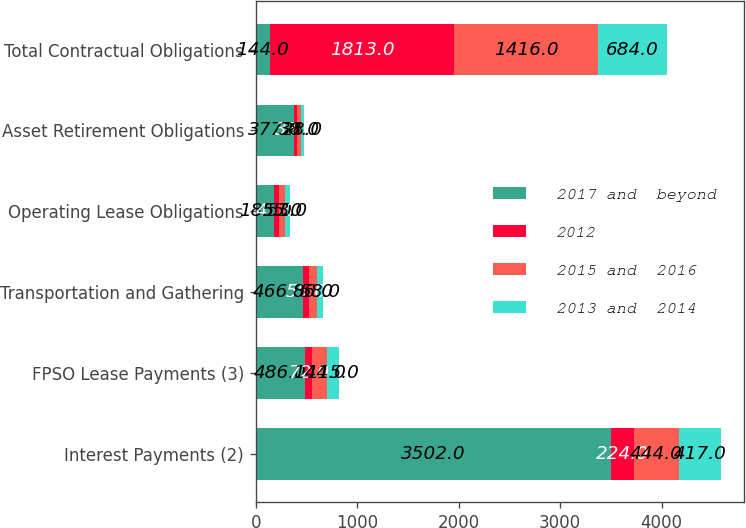Convert chart to OTSL. <chart><loc_0><loc_0><loc_500><loc_500><stacked_bar_chart><ecel><fcel>Interest Payments (2)<fcel>FPSO Lease Payments (3)<fcel>Transportation and Gathering<fcel>Operating Lease Obligations<fcel>Asset Retirement Obligations<fcel>Total Contractual Obligations<nl><fcel>2017 and  beyond<fcel>3502<fcel>486<fcel>466<fcel>185<fcel>377<fcel>144<nl><fcel>2012<fcel>224<fcel>72<fcel>55<fcel>45<fcel>33<fcel>1813<nl><fcel>2015 and  2016<fcel>444<fcel>144<fcel>86<fcel>55<fcel>38<fcel>1416<nl><fcel>2013 and  2014<fcel>417<fcel>115<fcel>58<fcel>53<fcel>28<fcel>684<nl></chart> 